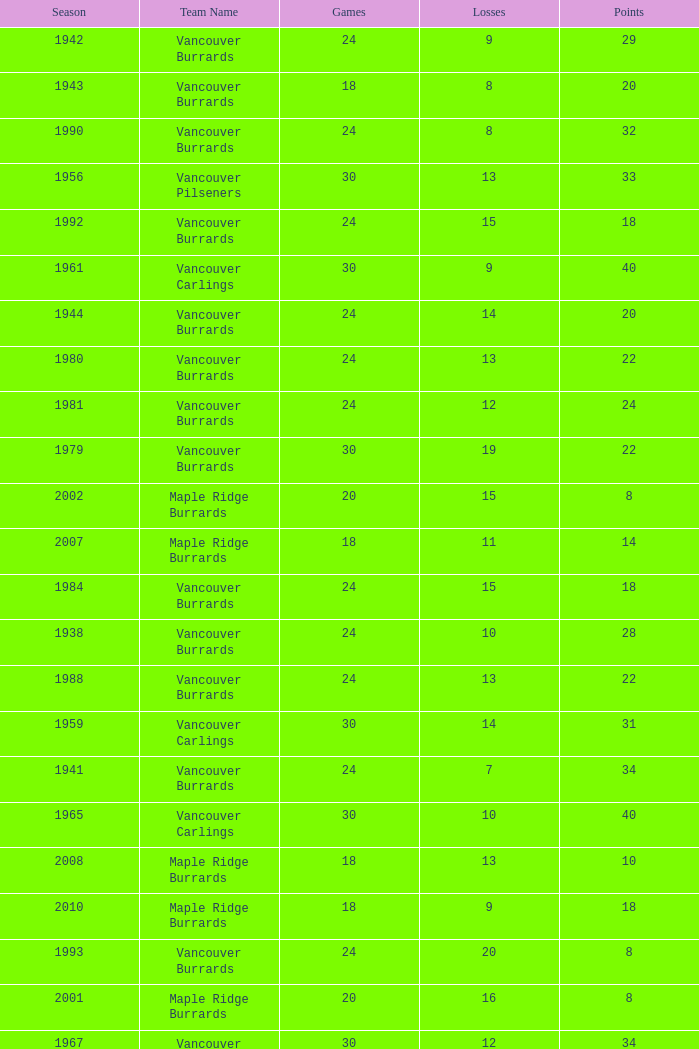What's the lowest number of points with fewer than 8 losses and fewer than 24 games for the vancouver burrards? 18.0. 